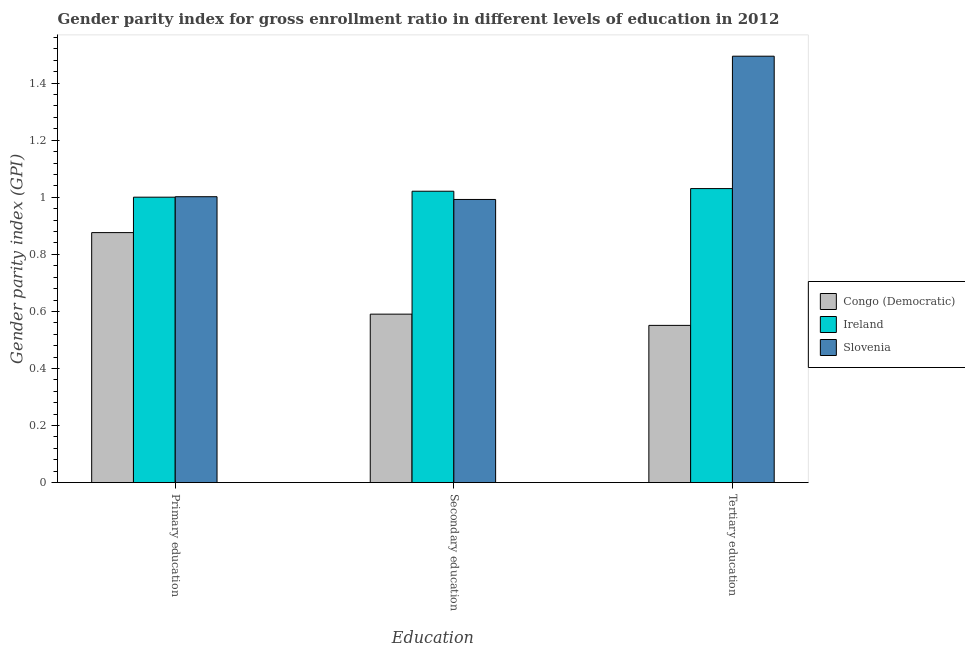How many groups of bars are there?
Your response must be concise. 3. Are the number of bars per tick equal to the number of legend labels?
Offer a very short reply. Yes. Are the number of bars on each tick of the X-axis equal?
Ensure brevity in your answer.  Yes. How many bars are there on the 1st tick from the left?
Make the answer very short. 3. What is the gender parity index in secondary education in Ireland?
Offer a terse response. 1.02. Across all countries, what is the maximum gender parity index in secondary education?
Make the answer very short. 1.02. Across all countries, what is the minimum gender parity index in primary education?
Ensure brevity in your answer.  0.88. In which country was the gender parity index in secondary education maximum?
Provide a succinct answer. Ireland. In which country was the gender parity index in secondary education minimum?
Your answer should be compact. Congo (Democratic). What is the total gender parity index in primary education in the graph?
Make the answer very short. 2.88. What is the difference between the gender parity index in primary education in Slovenia and that in Congo (Democratic)?
Ensure brevity in your answer.  0.13. What is the difference between the gender parity index in secondary education in Congo (Democratic) and the gender parity index in primary education in Slovenia?
Your answer should be very brief. -0.41. What is the average gender parity index in secondary education per country?
Offer a terse response. 0.87. What is the difference between the gender parity index in primary education and gender parity index in secondary education in Slovenia?
Keep it short and to the point. 0.01. In how many countries, is the gender parity index in tertiary education greater than 0.28 ?
Provide a short and direct response. 3. What is the ratio of the gender parity index in tertiary education in Ireland to that in Congo (Democratic)?
Ensure brevity in your answer.  1.87. Is the gender parity index in primary education in Ireland less than that in Congo (Democratic)?
Ensure brevity in your answer.  No. What is the difference between the highest and the second highest gender parity index in primary education?
Your response must be concise. 0. What is the difference between the highest and the lowest gender parity index in secondary education?
Provide a succinct answer. 0.43. In how many countries, is the gender parity index in tertiary education greater than the average gender parity index in tertiary education taken over all countries?
Your answer should be very brief. 2. Is the sum of the gender parity index in primary education in Slovenia and Congo (Democratic) greater than the maximum gender parity index in tertiary education across all countries?
Provide a succinct answer. Yes. What does the 2nd bar from the left in Tertiary education represents?
Your answer should be very brief. Ireland. What does the 3rd bar from the right in Secondary education represents?
Offer a very short reply. Congo (Democratic). Is it the case that in every country, the sum of the gender parity index in primary education and gender parity index in secondary education is greater than the gender parity index in tertiary education?
Make the answer very short. Yes. How many bars are there?
Your answer should be very brief. 9. Are all the bars in the graph horizontal?
Offer a very short reply. No. How many countries are there in the graph?
Your answer should be compact. 3. Are the values on the major ticks of Y-axis written in scientific E-notation?
Your answer should be very brief. No. How many legend labels are there?
Provide a short and direct response. 3. What is the title of the graph?
Provide a short and direct response. Gender parity index for gross enrollment ratio in different levels of education in 2012. Does "Micronesia" appear as one of the legend labels in the graph?
Your answer should be very brief. No. What is the label or title of the X-axis?
Offer a terse response. Education. What is the label or title of the Y-axis?
Offer a terse response. Gender parity index (GPI). What is the Gender parity index (GPI) of Congo (Democratic) in Primary education?
Your answer should be very brief. 0.88. What is the Gender parity index (GPI) of Ireland in Primary education?
Keep it short and to the point. 1. What is the Gender parity index (GPI) in Slovenia in Primary education?
Your answer should be very brief. 1. What is the Gender parity index (GPI) in Congo (Democratic) in Secondary education?
Keep it short and to the point. 0.59. What is the Gender parity index (GPI) in Ireland in Secondary education?
Make the answer very short. 1.02. What is the Gender parity index (GPI) in Slovenia in Secondary education?
Ensure brevity in your answer.  0.99. What is the Gender parity index (GPI) of Congo (Democratic) in Tertiary education?
Your answer should be very brief. 0.55. What is the Gender parity index (GPI) in Ireland in Tertiary education?
Your response must be concise. 1.03. What is the Gender parity index (GPI) of Slovenia in Tertiary education?
Ensure brevity in your answer.  1.49. Across all Education, what is the maximum Gender parity index (GPI) in Congo (Democratic)?
Make the answer very short. 0.88. Across all Education, what is the maximum Gender parity index (GPI) of Ireland?
Your answer should be very brief. 1.03. Across all Education, what is the maximum Gender parity index (GPI) in Slovenia?
Provide a succinct answer. 1.49. Across all Education, what is the minimum Gender parity index (GPI) of Congo (Democratic)?
Your response must be concise. 0.55. Across all Education, what is the minimum Gender parity index (GPI) of Ireland?
Provide a succinct answer. 1. Across all Education, what is the minimum Gender parity index (GPI) in Slovenia?
Give a very brief answer. 0.99. What is the total Gender parity index (GPI) in Congo (Democratic) in the graph?
Your response must be concise. 2.02. What is the total Gender parity index (GPI) in Ireland in the graph?
Provide a short and direct response. 3.05. What is the total Gender parity index (GPI) of Slovenia in the graph?
Keep it short and to the point. 3.49. What is the difference between the Gender parity index (GPI) of Congo (Democratic) in Primary education and that in Secondary education?
Provide a succinct answer. 0.29. What is the difference between the Gender parity index (GPI) in Ireland in Primary education and that in Secondary education?
Your response must be concise. -0.02. What is the difference between the Gender parity index (GPI) of Slovenia in Primary education and that in Secondary education?
Keep it short and to the point. 0.01. What is the difference between the Gender parity index (GPI) in Congo (Democratic) in Primary education and that in Tertiary education?
Your response must be concise. 0.33. What is the difference between the Gender parity index (GPI) of Ireland in Primary education and that in Tertiary education?
Ensure brevity in your answer.  -0.03. What is the difference between the Gender parity index (GPI) in Slovenia in Primary education and that in Tertiary education?
Give a very brief answer. -0.49. What is the difference between the Gender parity index (GPI) in Congo (Democratic) in Secondary education and that in Tertiary education?
Your answer should be very brief. 0.04. What is the difference between the Gender parity index (GPI) in Ireland in Secondary education and that in Tertiary education?
Give a very brief answer. -0.01. What is the difference between the Gender parity index (GPI) in Slovenia in Secondary education and that in Tertiary education?
Offer a terse response. -0.5. What is the difference between the Gender parity index (GPI) in Congo (Democratic) in Primary education and the Gender parity index (GPI) in Ireland in Secondary education?
Your answer should be compact. -0.14. What is the difference between the Gender parity index (GPI) in Congo (Democratic) in Primary education and the Gender parity index (GPI) in Slovenia in Secondary education?
Provide a short and direct response. -0.12. What is the difference between the Gender parity index (GPI) of Ireland in Primary education and the Gender parity index (GPI) of Slovenia in Secondary education?
Keep it short and to the point. 0.01. What is the difference between the Gender parity index (GPI) of Congo (Democratic) in Primary education and the Gender parity index (GPI) of Ireland in Tertiary education?
Offer a very short reply. -0.15. What is the difference between the Gender parity index (GPI) in Congo (Democratic) in Primary education and the Gender parity index (GPI) in Slovenia in Tertiary education?
Offer a terse response. -0.62. What is the difference between the Gender parity index (GPI) of Ireland in Primary education and the Gender parity index (GPI) of Slovenia in Tertiary education?
Provide a succinct answer. -0.49. What is the difference between the Gender parity index (GPI) in Congo (Democratic) in Secondary education and the Gender parity index (GPI) in Ireland in Tertiary education?
Make the answer very short. -0.44. What is the difference between the Gender parity index (GPI) of Congo (Democratic) in Secondary education and the Gender parity index (GPI) of Slovenia in Tertiary education?
Offer a very short reply. -0.9. What is the difference between the Gender parity index (GPI) of Ireland in Secondary education and the Gender parity index (GPI) of Slovenia in Tertiary education?
Make the answer very short. -0.47. What is the average Gender parity index (GPI) of Congo (Democratic) per Education?
Keep it short and to the point. 0.67. What is the average Gender parity index (GPI) in Ireland per Education?
Provide a succinct answer. 1.02. What is the average Gender parity index (GPI) in Slovenia per Education?
Give a very brief answer. 1.16. What is the difference between the Gender parity index (GPI) in Congo (Democratic) and Gender parity index (GPI) in Ireland in Primary education?
Offer a very short reply. -0.12. What is the difference between the Gender parity index (GPI) in Congo (Democratic) and Gender parity index (GPI) in Slovenia in Primary education?
Ensure brevity in your answer.  -0.13. What is the difference between the Gender parity index (GPI) in Ireland and Gender parity index (GPI) in Slovenia in Primary education?
Give a very brief answer. -0. What is the difference between the Gender parity index (GPI) of Congo (Democratic) and Gender parity index (GPI) of Ireland in Secondary education?
Keep it short and to the point. -0.43. What is the difference between the Gender parity index (GPI) in Congo (Democratic) and Gender parity index (GPI) in Slovenia in Secondary education?
Make the answer very short. -0.4. What is the difference between the Gender parity index (GPI) in Ireland and Gender parity index (GPI) in Slovenia in Secondary education?
Ensure brevity in your answer.  0.03. What is the difference between the Gender parity index (GPI) in Congo (Democratic) and Gender parity index (GPI) in Ireland in Tertiary education?
Give a very brief answer. -0.48. What is the difference between the Gender parity index (GPI) in Congo (Democratic) and Gender parity index (GPI) in Slovenia in Tertiary education?
Offer a terse response. -0.94. What is the difference between the Gender parity index (GPI) of Ireland and Gender parity index (GPI) of Slovenia in Tertiary education?
Provide a short and direct response. -0.46. What is the ratio of the Gender parity index (GPI) in Congo (Democratic) in Primary education to that in Secondary education?
Ensure brevity in your answer.  1.48. What is the ratio of the Gender parity index (GPI) of Ireland in Primary education to that in Secondary education?
Your answer should be very brief. 0.98. What is the ratio of the Gender parity index (GPI) of Slovenia in Primary education to that in Secondary education?
Your answer should be very brief. 1.01. What is the ratio of the Gender parity index (GPI) in Congo (Democratic) in Primary education to that in Tertiary education?
Your answer should be compact. 1.59. What is the ratio of the Gender parity index (GPI) in Ireland in Primary education to that in Tertiary education?
Your answer should be compact. 0.97. What is the ratio of the Gender parity index (GPI) of Slovenia in Primary education to that in Tertiary education?
Make the answer very short. 0.67. What is the ratio of the Gender parity index (GPI) of Congo (Democratic) in Secondary education to that in Tertiary education?
Your answer should be very brief. 1.07. What is the ratio of the Gender parity index (GPI) in Ireland in Secondary education to that in Tertiary education?
Provide a short and direct response. 0.99. What is the ratio of the Gender parity index (GPI) of Slovenia in Secondary education to that in Tertiary education?
Your answer should be compact. 0.66. What is the difference between the highest and the second highest Gender parity index (GPI) in Congo (Democratic)?
Ensure brevity in your answer.  0.29. What is the difference between the highest and the second highest Gender parity index (GPI) in Ireland?
Provide a succinct answer. 0.01. What is the difference between the highest and the second highest Gender parity index (GPI) in Slovenia?
Make the answer very short. 0.49. What is the difference between the highest and the lowest Gender parity index (GPI) in Congo (Democratic)?
Your response must be concise. 0.33. What is the difference between the highest and the lowest Gender parity index (GPI) of Ireland?
Offer a terse response. 0.03. What is the difference between the highest and the lowest Gender parity index (GPI) of Slovenia?
Your response must be concise. 0.5. 